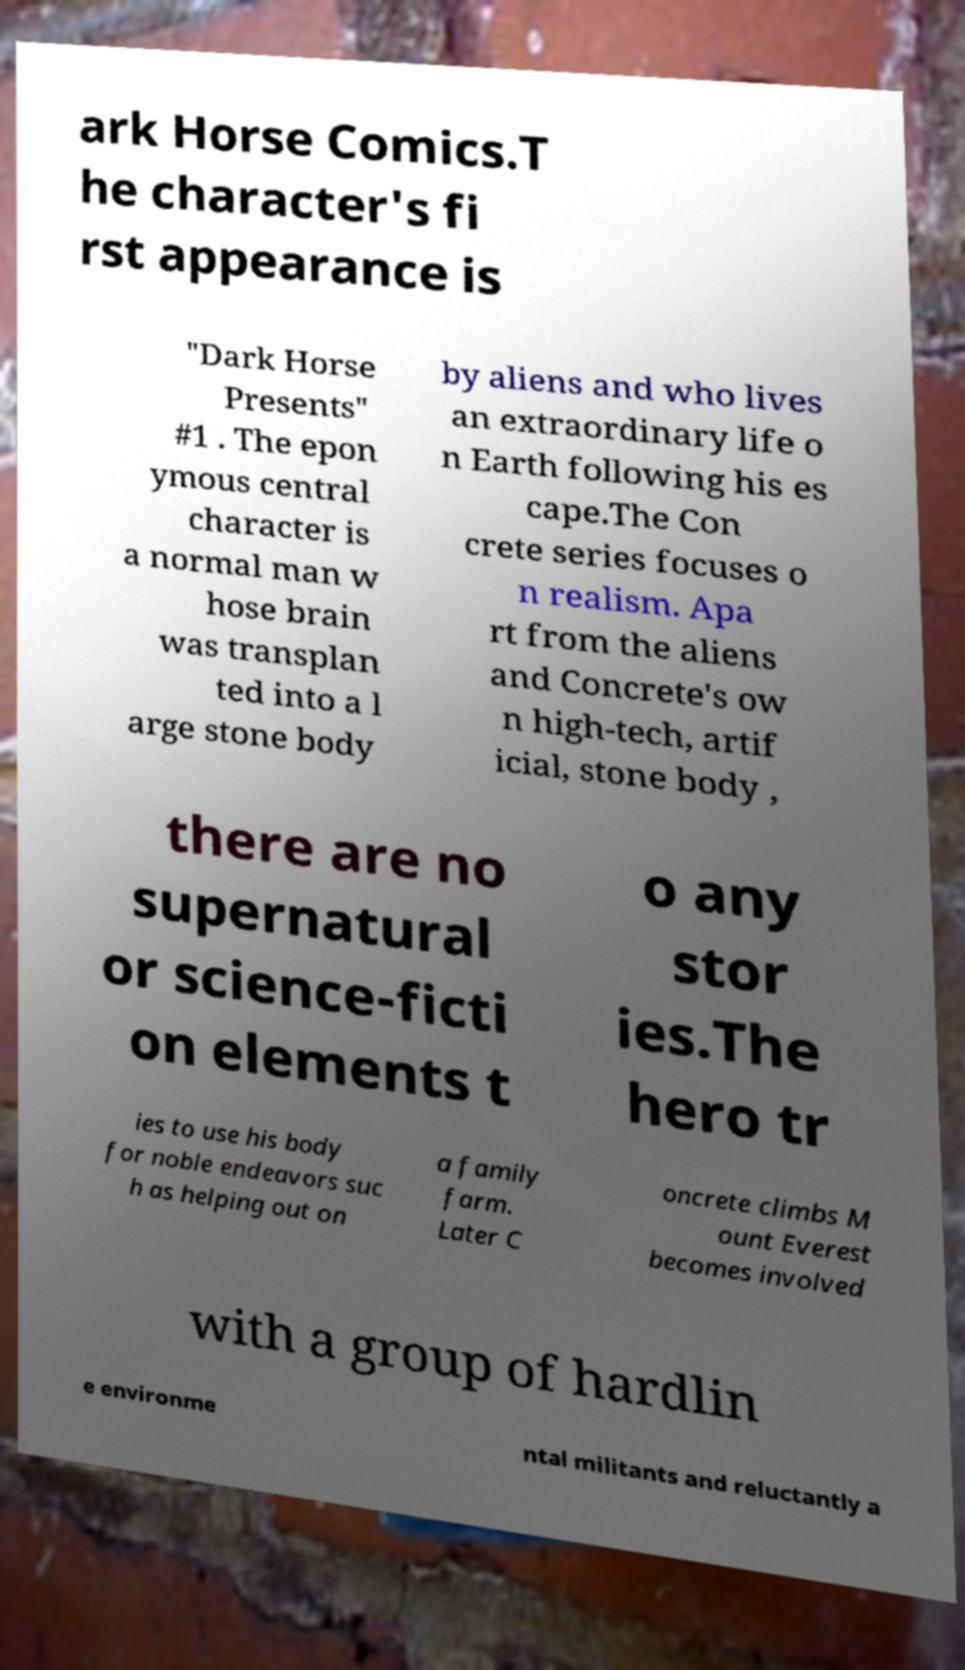There's text embedded in this image that I need extracted. Can you transcribe it verbatim? ark Horse Comics.T he character's fi rst appearance is "Dark Horse Presents" #1 . The epon ymous central character is a normal man w hose brain was transplan ted into a l arge stone body by aliens and who lives an extraordinary life o n Earth following his es cape.The Con crete series focuses o n realism. Apa rt from the aliens and Concrete's ow n high-tech, artif icial, stone body , there are no supernatural or science-ficti on elements t o any stor ies.The hero tr ies to use his body for noble endeavors suc h as helping out on a family farm. Later C oncrete climbs M ount Everest becomes involved with a group of hardlin e environme ntal militants and reluctantly a 